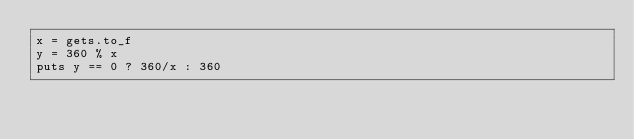Convert code to text. <code><loc_0><loc_0><loc_500><loc_500><_Ruby_>x = gets.to_f
y = 360 % x
puts y == 0 ? 360/x : 360</code> 